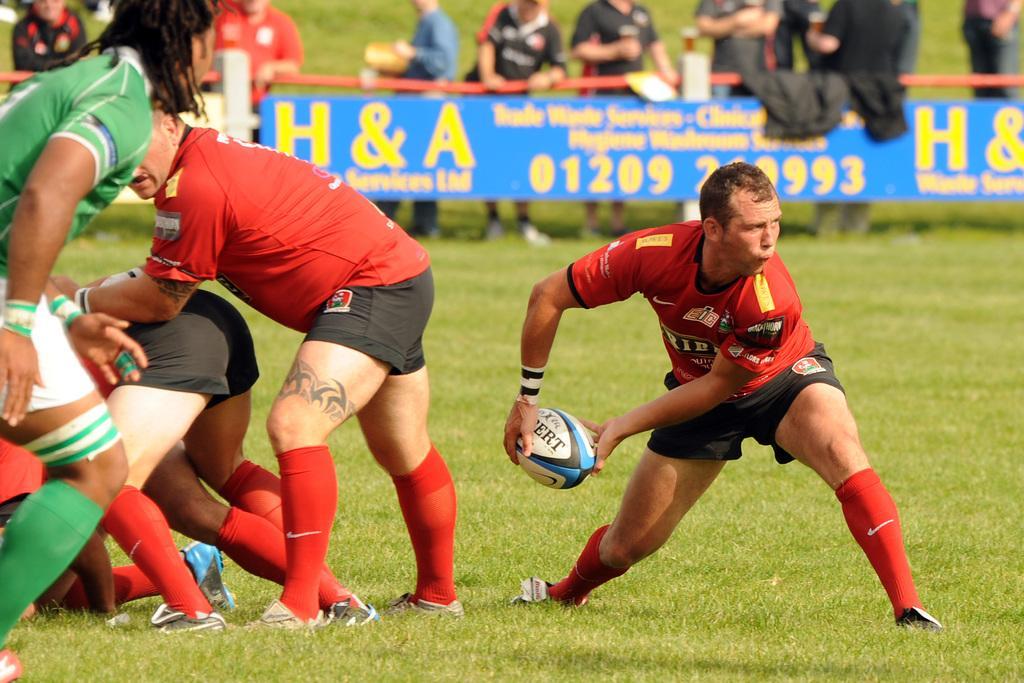Describe this image in one or two sentences. This picture shows a group of people playing american football 